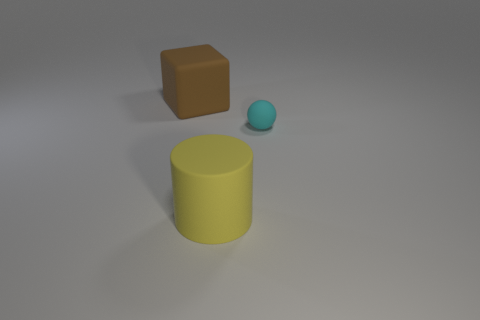Are there any other things that have the same size as the rubber sphere?
Offer a very short reply. No. There is a rubber object that is behind the large matte cylinder and left of the tiny matte thing; what size is it?
Provide a succinct answer. Large. Is the shape of the tiny matte thing the same as the large brown matte thing?
Offer a terse response. No. There is a big yellow object that is the same material as the cyan sphere; what is its shape?
Your response must be concise. Cylinder. How many small objects are yellow rubber things or yellow shiny cylinders?
Ensure brevity in your answer.  0. Are there any brown matte objects in front of the big matte object right of the big brown matte block?
Provide a succinct answer. No. Is there a cyan rubber cube?
Provide a succinct answer. No. What is the color of the rubber thing that is left of the big rubber thing that is in front of the small sphere?
Your response must be concise. Brown. How many cyan balls are the same size as the yellow object?
Your answer should be compact. 0. What is the size of the yellow object that is the same material as the brown object?
Provide a succinct answer. Large. 